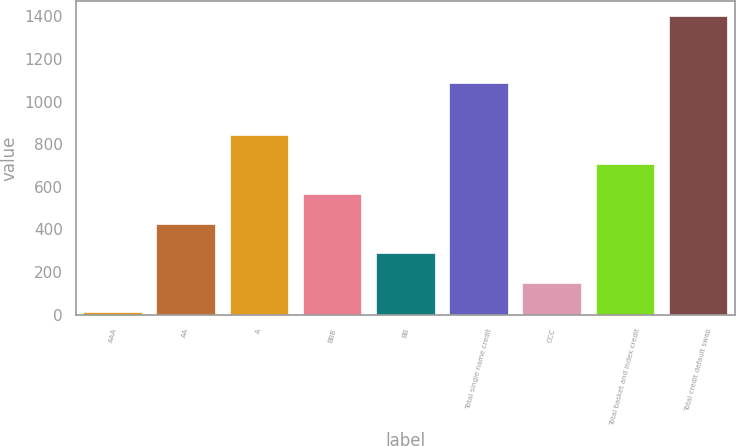Convert chart. <chart><loc_0><loc_0><loc_500><loc_500><bar_chart><fcel>AAA<fcel>AA<fcel>A<fcel>BBB<fcel>BB<fcel>Total single name credit<fcel>CCC<fcel>Total basket and index credit<fcel>Total credit default swap<nl><fcel>10<fcel>426.97<fcel>843.94<fcel>565.96<fcel>287.98<fcel>1084.9<fcel>148.99<fcel>704.95<fcel>1399.9<nl></chart> 